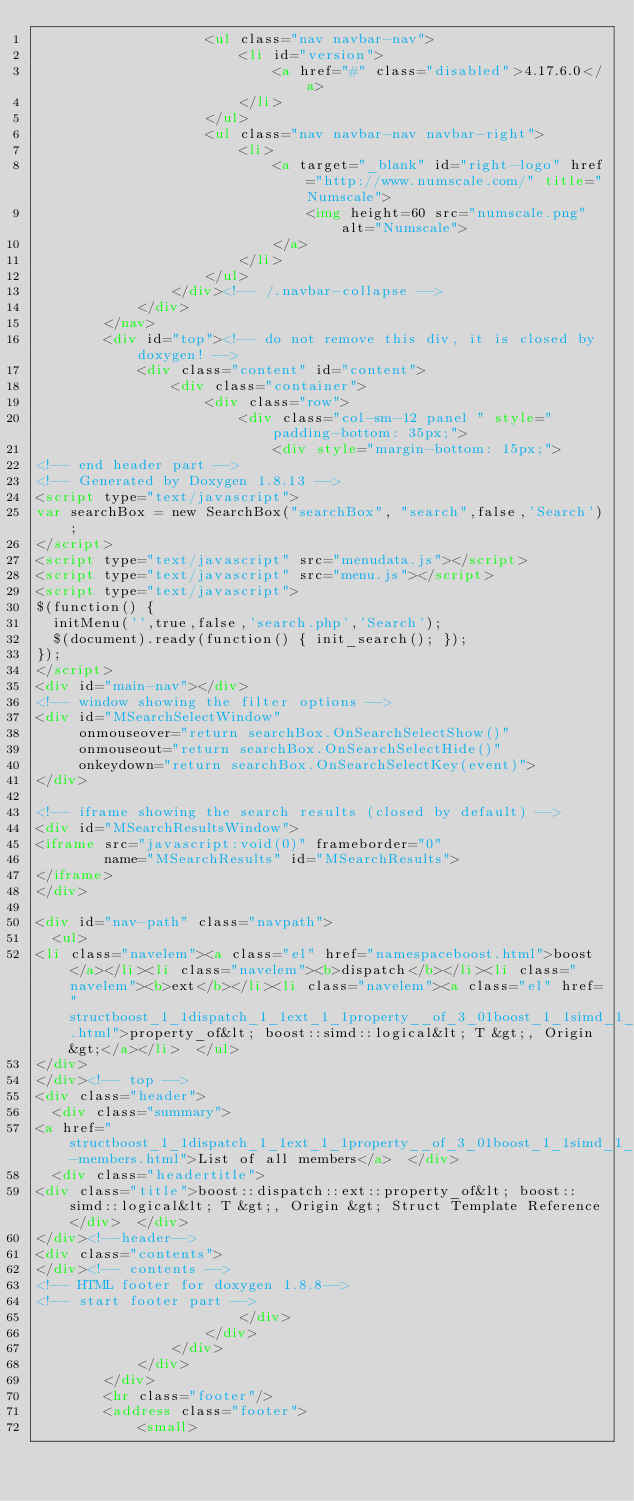<code> <loc_0><loc_0><loc_500><loc_500><_HTML_>                    <ul class="nav navbar-nav">
                        <li id="version">
                            <a href="#" class="disabled">4.17.6.0</a>
                        </li>
                    </ul>
                    <ul class="nav navbar-nav navbar-right">
                        <li>
                            <a target="_blank" id="right-logo" href="http://www.numscale.com/" title="Numscale">
                                <img height=60 src="numscale.png" alt="Numscale">
                            </a>
                        </li>
                    </ul>
                </div><!-- /.navbar-collapse -->
            </div>
        </nav>
        <div id="top"><!-- do not remove this div, it is closed by doxygen! -->
            <div class="content" id="content">
                <div class="container">
                    <div class="row">
                        <div class="col-sm-12 panel " style="padding-bottom: 35px;">
                            <div style="margin-bottom: 15px;">
<!-- end header part -->
<!-- Generated by Doxygen 1.8.13 -->
<script type="text/javascript">
var searchBox = new SearchBox("searchBox", "search",false,'Search');
</script>
<script type="text/javascript" src="menudata.js"></script>
<script type="text/javascript" src="menu.js"></script>
<script type="text/javascript">
$(function() {
  initMenu('',true,false,'search.php','Search');
  $(document).ready(function() { init_search(); });
});
</script>
<div id="main-nav"></div>
<!-- window showing the filter options -->
<div id="MSearchSelectWindow"
     onmouseover="return searchBox.OnSearchSelectShow()"
     onmouseout="return searchBox.OnSearchSelectHide()"
     onkeydown="return searchBox.OnSearchSelectKey(event)">
</div>

<!-- iframe showing the search results (closed by default) -->
<div id="MSearchResultsWindow">
<iframe src="javascript:void(0)" frameborder="0" 
        name="MSearchResults" id="MSearchResults">
</iframe>
</div>

<div id="nav-path" class="navpath">
  <ul>
<li class="navelem"><a class="el" href="namespaceboost.html">boost</a></li><li class="navelem"><b>dispatch</b></li><li class="navelem"><b>ext</b></li><li class="navelem"><a class="el" href="structboost_1_1dispatch_1_1ext_1_1property__of_3_01boost_1_1simd_1_1logical_3_01_t_01_4_00_01_origin_01_4.html">property_of&lt; boost::simd::logical&lt; T &gt;, Origin &gt;</a></li>  </ul>
</div>
</div><!-- top -->
<div class="header">
  <div class="summary">
<a href="structboost_1_1dispatch_1_1ext_1_1property__of_3_01boost_1_1simd_1_1logical_3_01_t_01_4_00_01_origin_01_4-members.html">List of all members</a>  </div>
  <div class="headertitle">
<div class="title">boost::dispatch::ext::property_of&lt; boost::simd::logical&lt; T &gt;, Origin &gt; Struct Template Reference</div>  </div>
</div><!--header-->
<div class="contents">
</div><!-- contents -->
<!-- HTML footer for doxygen 1.8.8-->
<!-- start footer part -->
                        </div>
                    </div>
                </div>
            </div>
        </div>
        <hr class="footer"/>
        <address class="footer">
            <small></code> 